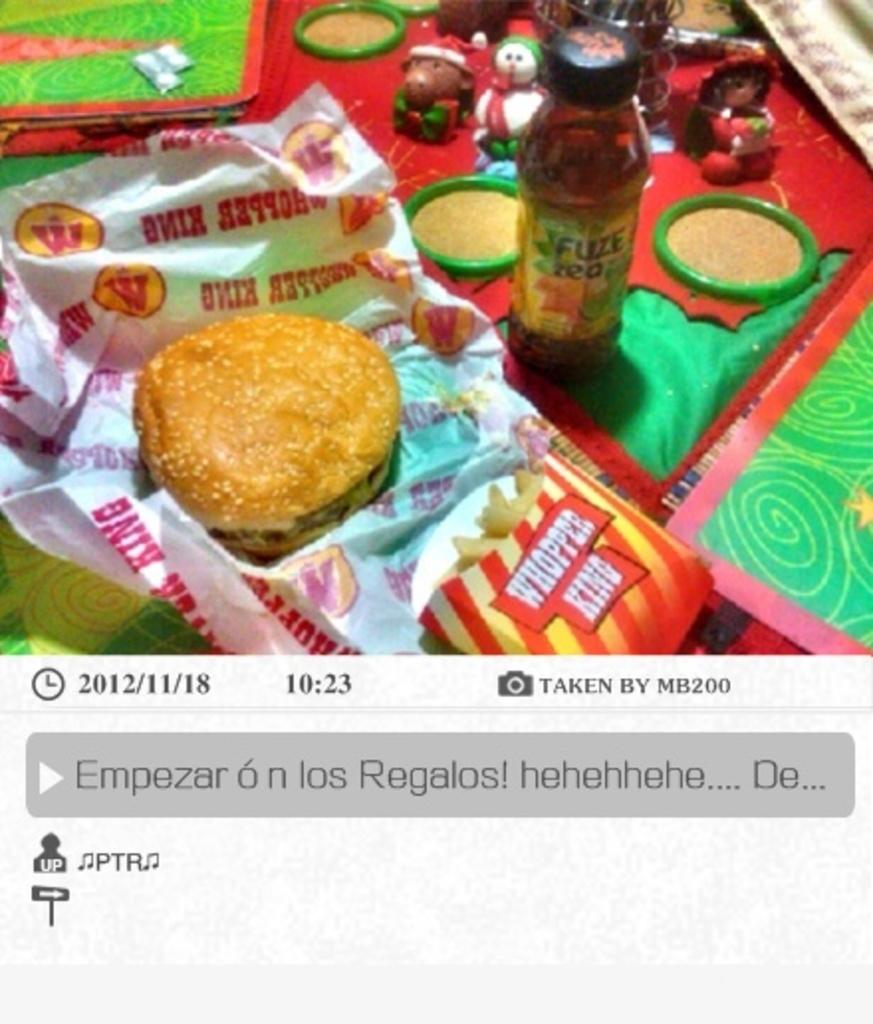What type of food is the main subject of the image? There is a burger in the image. What else can be seen on the table in the image? There is a bottle on the table in the image. What side dish is present in the image? There are french fries ines in the image. What other objects are on the table in the image? There are objects on the table in the image, but their specific details are not mentioned in the provided facts. What color is the chalk used to draw on the bread in the image? There is no chalk or bread present in the image; it features a burger, a bottle, and french fries on a table. 